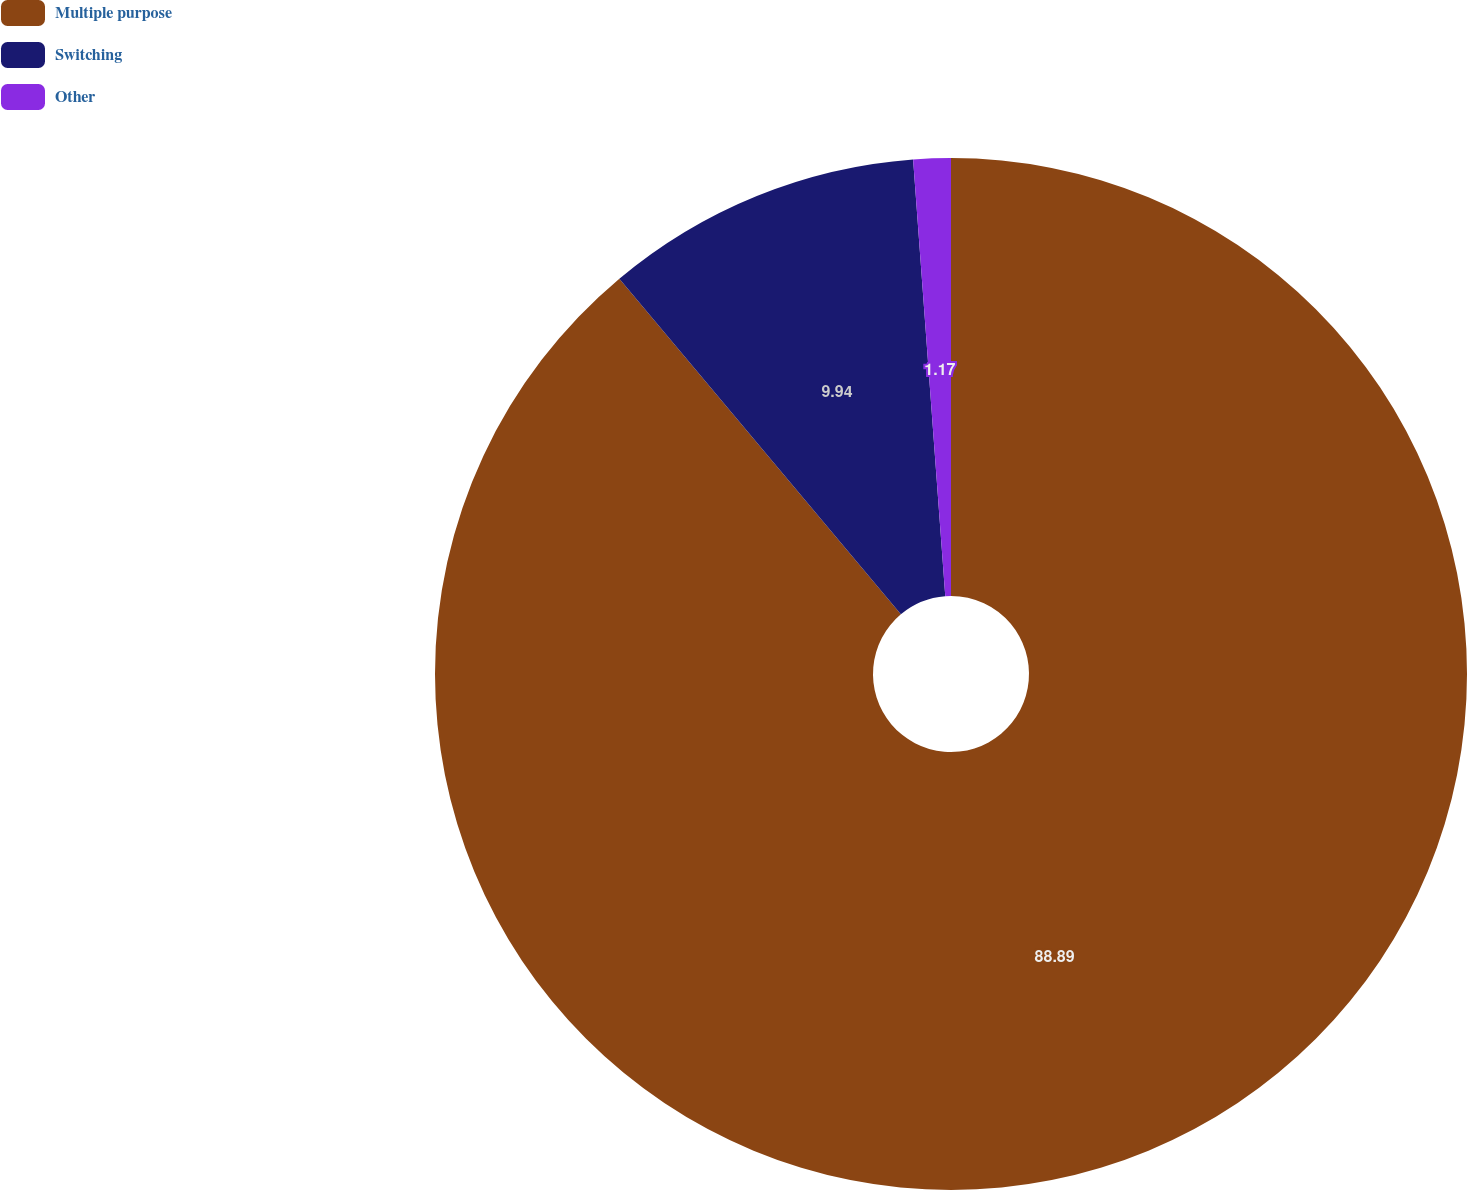Convert chart to OTSL. <chart><loc_0><loc_0><loc_500><loc_500><pie_chart><fcel>Multiple purpose<fcel>Switching<fcel>Other<nl><fcel>88.89%<fcel>9.94%<fcel>1.17%<nl></chart> 